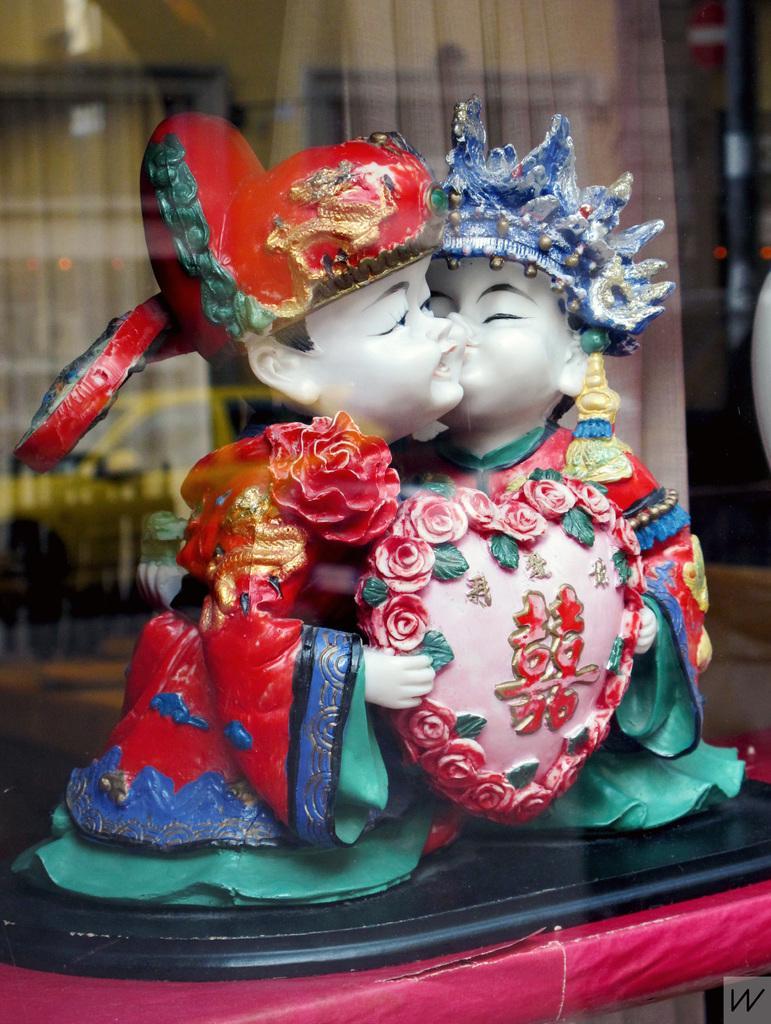Can you describe this image briefly? In this image we can see a statue which is placed on the surface. On the backside we can see a glass window and the curtains. 